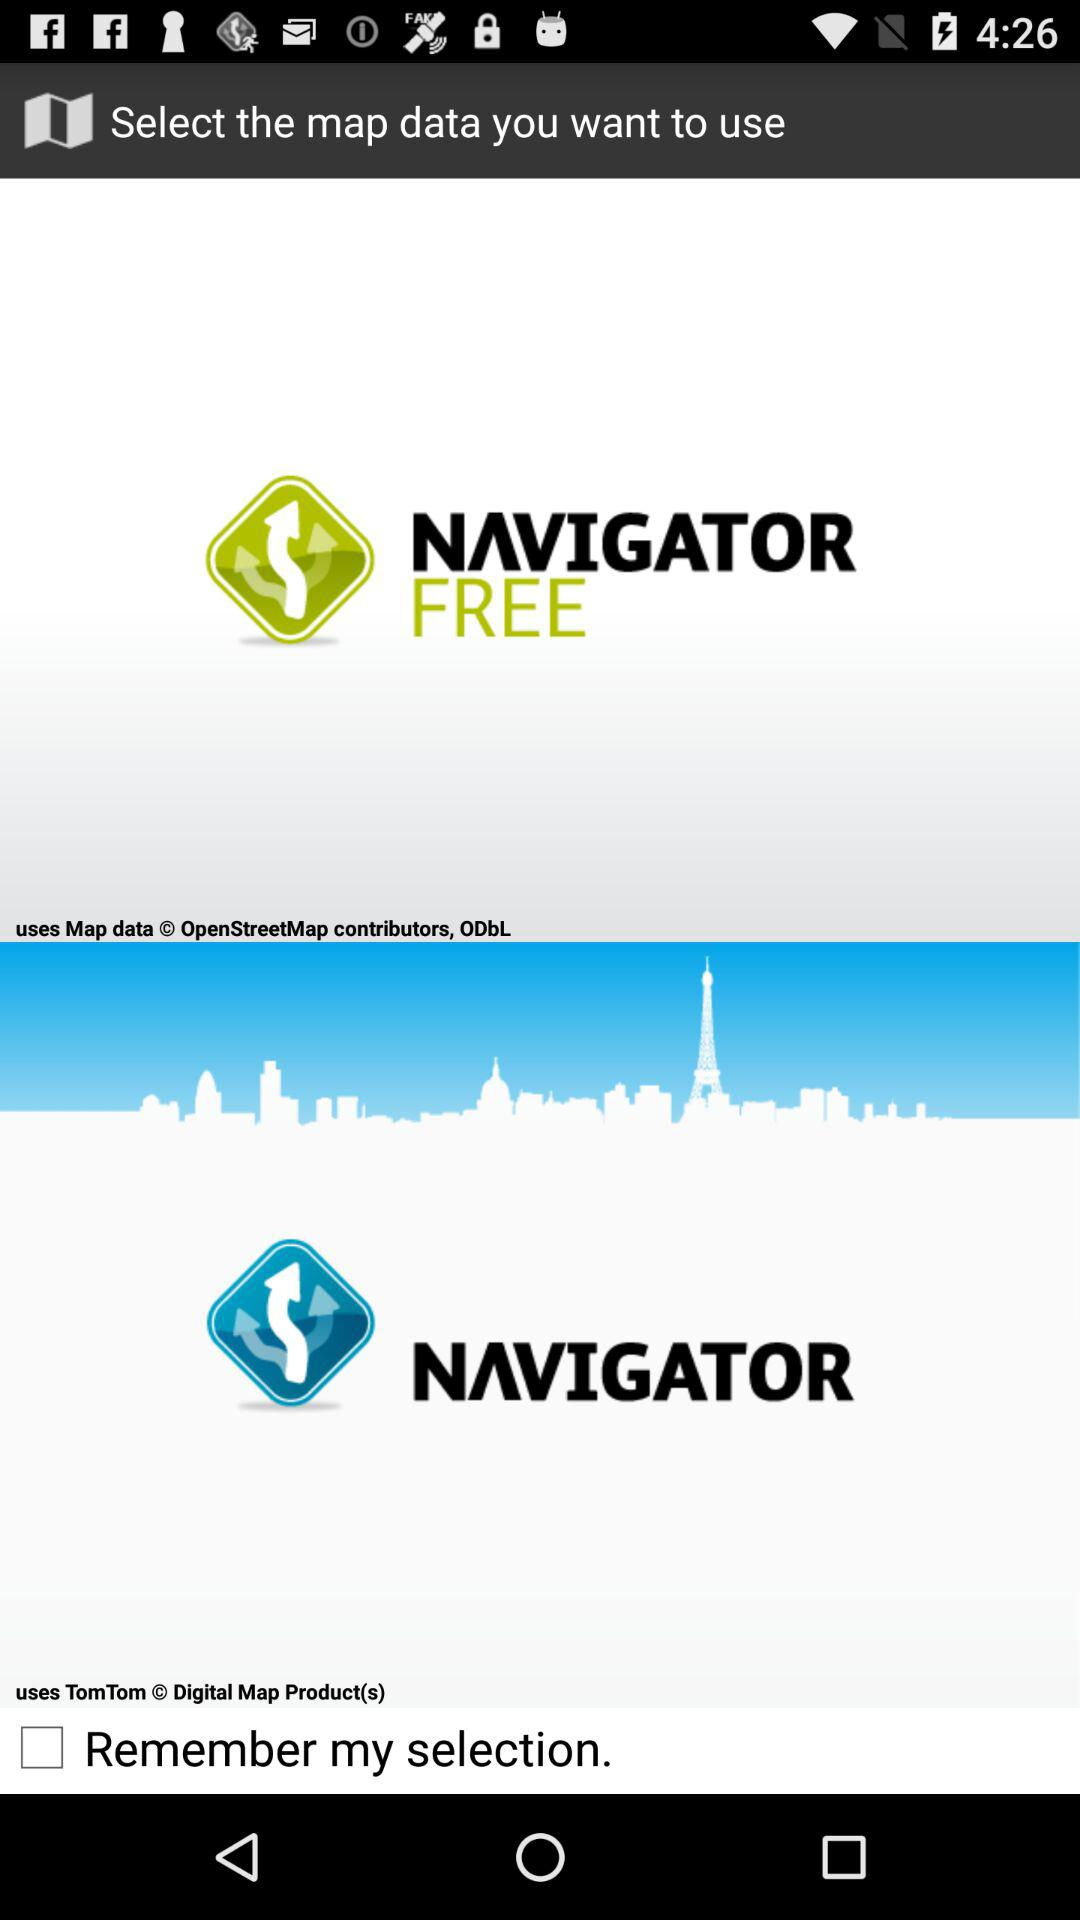Which options are there to select the map data? The options are "NAVIGATOR FREE" and "NAVIGATOR". 